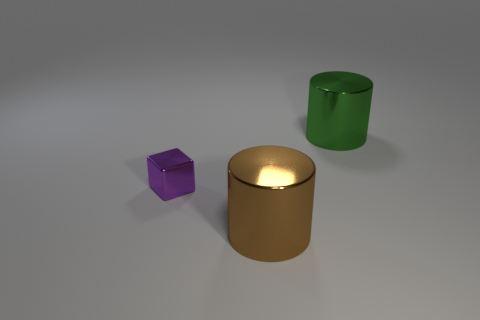Add 1 green objects. How many objects exist? 4 Subtract all cylinders. How many objects are left? 1 Subtract 1 green cylinders. How many objects are left? 2 Subtract all purple shiny cylinders. Subtract all brown metal cylinders. How many objects are left? 2 Add 2 cylinders. How many cylinders are left? 4 Add 3 big objects. How many big objects exist? 5 